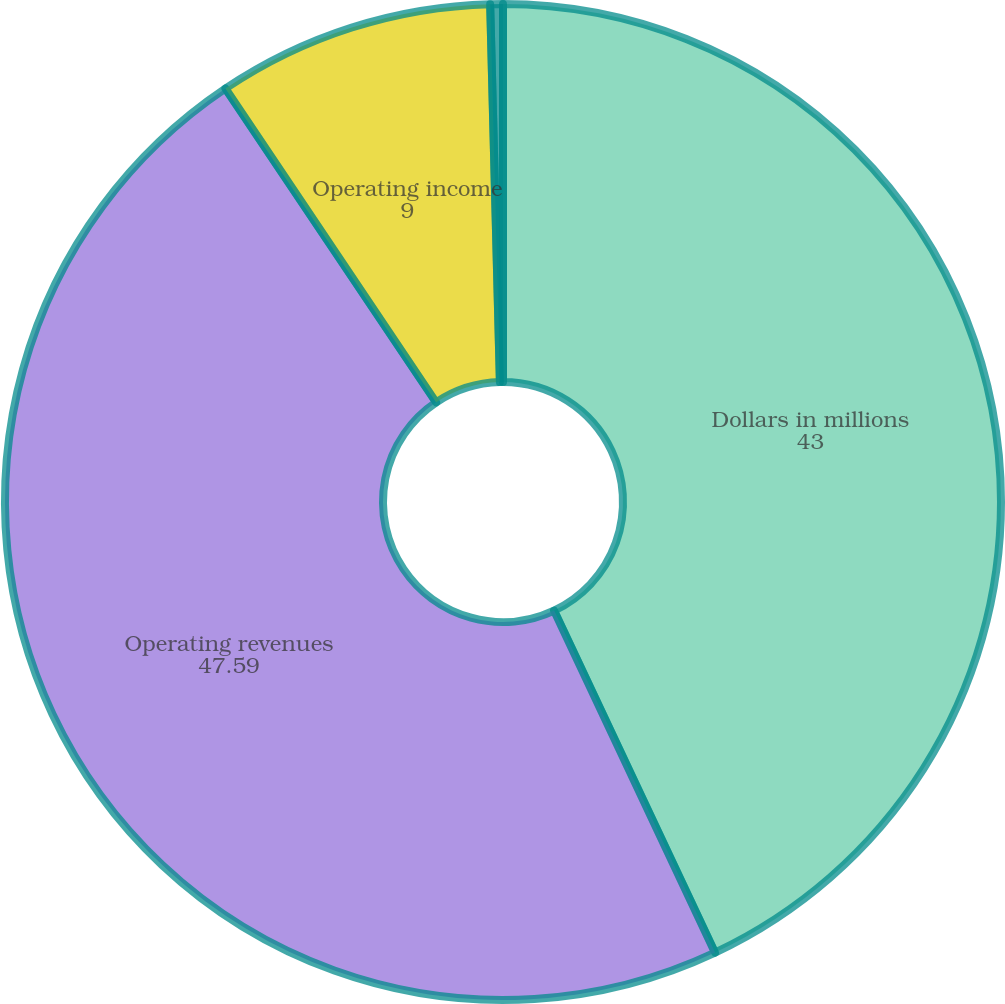Convert chart to OTSL. <chart><loc_0><loc_0><loc_500><loc_500><pie_chart><fcel>Dollars in millions<fcel>Operating revenues<fcel>Operating income<fcel>Margin<nl><fcel>43.0%<fcel>47.59%<fcel>9.0%<fcel>0.41%<nl></chart> 